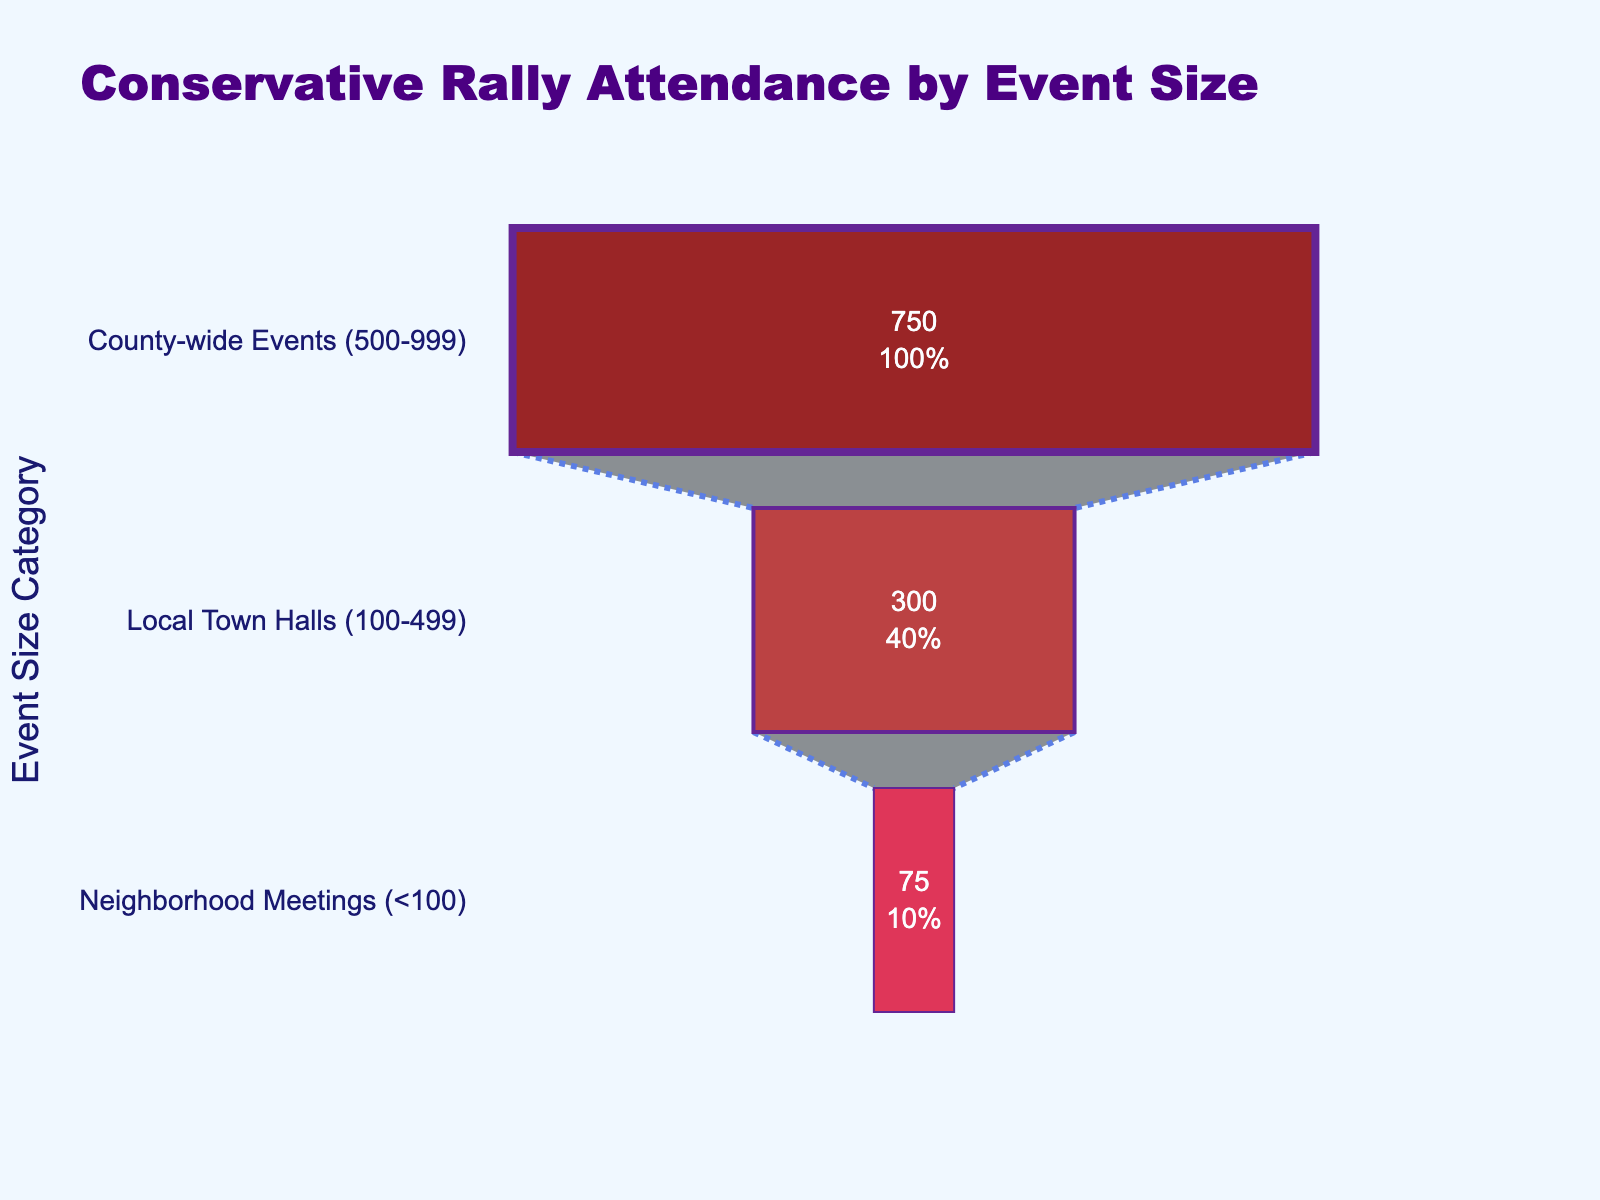What's the title of the figure? The title of the figure is the large text at the top of the chart.
Answer: Conservative Rally Attendance by Event Size What is the attendance for Local Town Halls? Read the value corresponding to "Local Town Halls (100-499)" on the funnel chart.
Answer: 300 Which event size category has the lowest attendance? Compare the attendance values of all event size categories.
Answer: Neighborhood Meetings (<100) What is the total attendance across all event size categories? Sum the attendance values of all the event sizes: 750 (County-wide Events) + 300 (Local Town Halls) + 75 (Neighborhood Meetings) = 1125.
Answer: 1125 How much greater is the attendance for County-wide Events compared to Neighborhood Meetings? Subtract the attendance of Neighborhood Meetings from County-wide Events: 750 - 75 = 675.
Answer: 675 What percentage of the total attendance is from Local Town Halls? Calculate Local Town Halls' percentage of the total attendance: (300 / 1125) * 100%.
Answer: 26.67% Between Local Town Halls and Neighborhood Meetings, which category has a higher attendance? Compare the attendance values of Local Town Halls and Neighborhood Meetings: 300 for Local Town Halls is greater than 75 for Neighborhood Meetings.
Answer: Local Town Halls How many colors are used in the chart's segments? Count the distinct colors of the funnel's segments.
Answer: 3 What is the event size category with the highest attendance? Identify the category with the largest value.
Answer: County-wide Events (500-999) Describe the appearance of the connectors in the funnel chart. The connectors are lines with a dash-dot pattern, colored in royal blue.
Answer: Dash-dot royal blue lines 